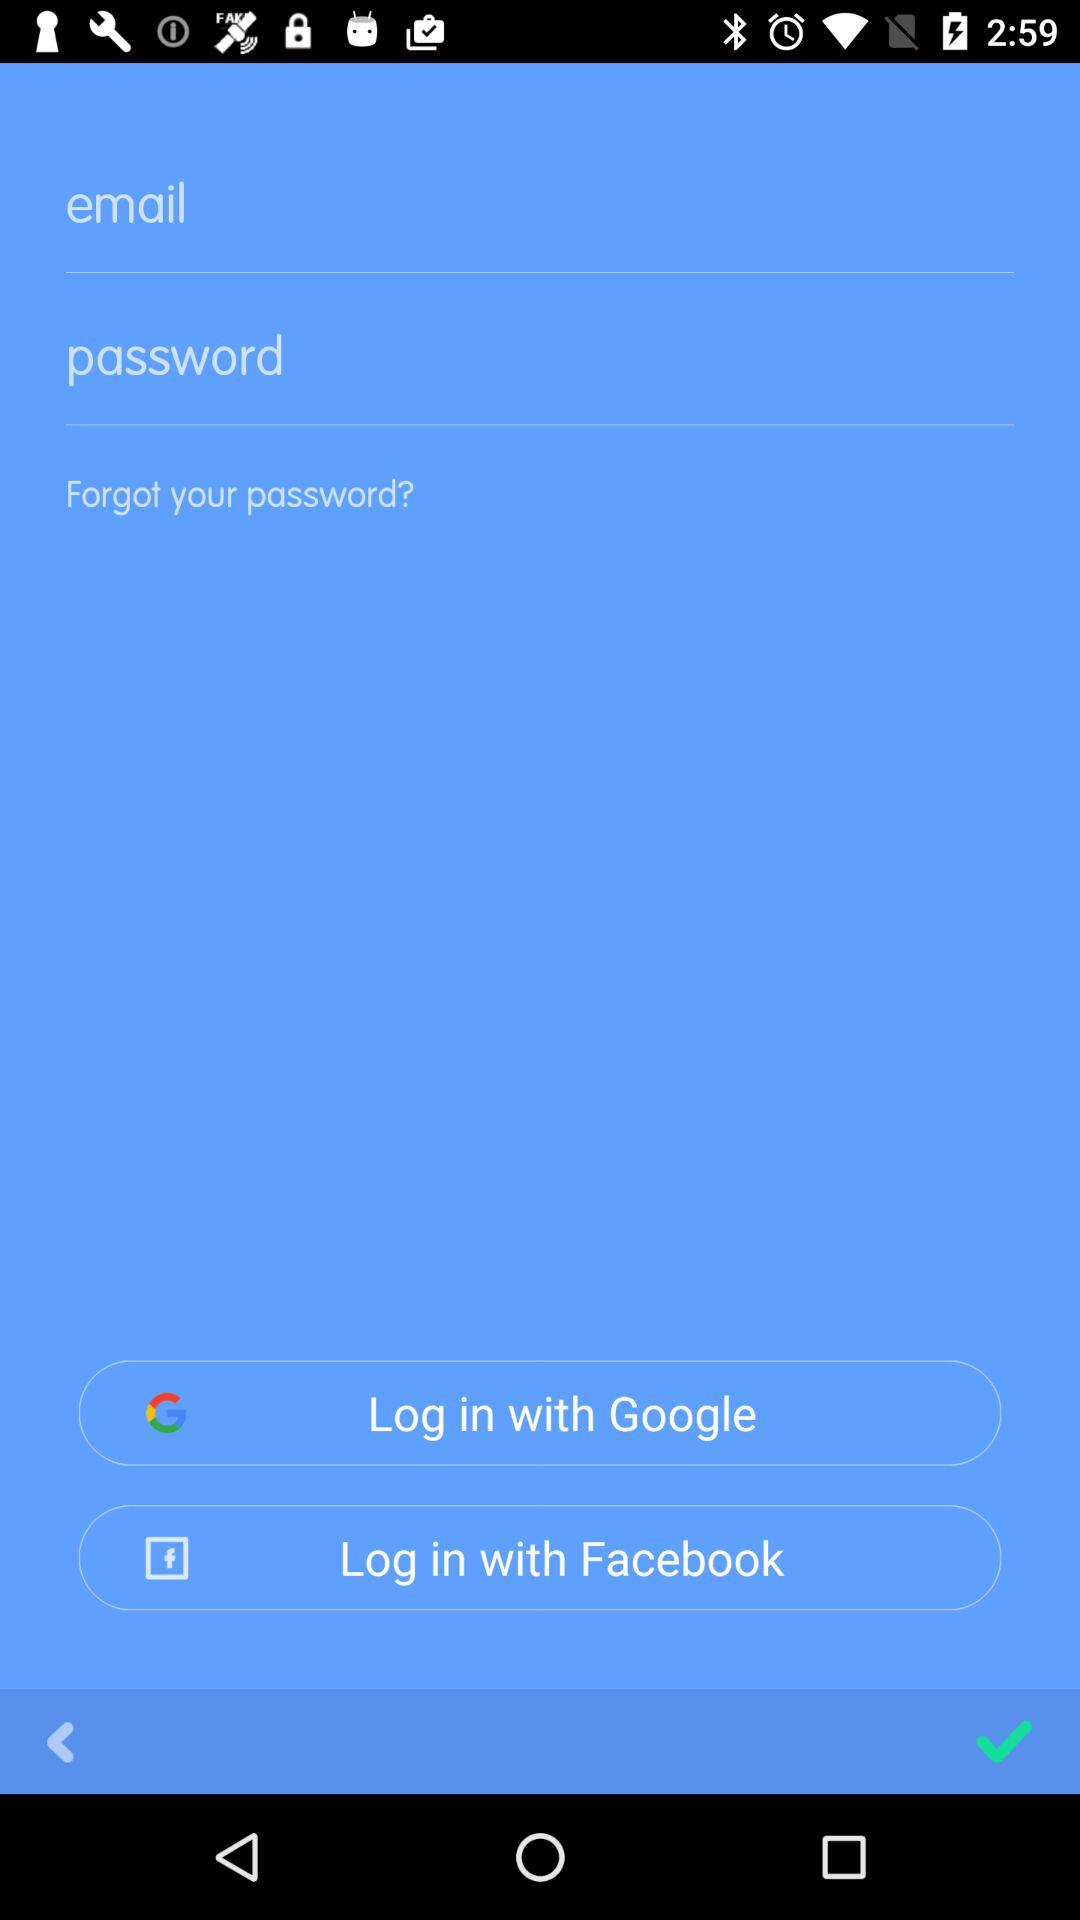Which social apps can we use to log in? You can use "Google" and "Facebook" to log in. 